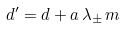<formula> <loc_0><loc_0><loc_500><loc_500>d ^ { \prime } = d + a \, \lambda _ { \pm } \, m</formula> 